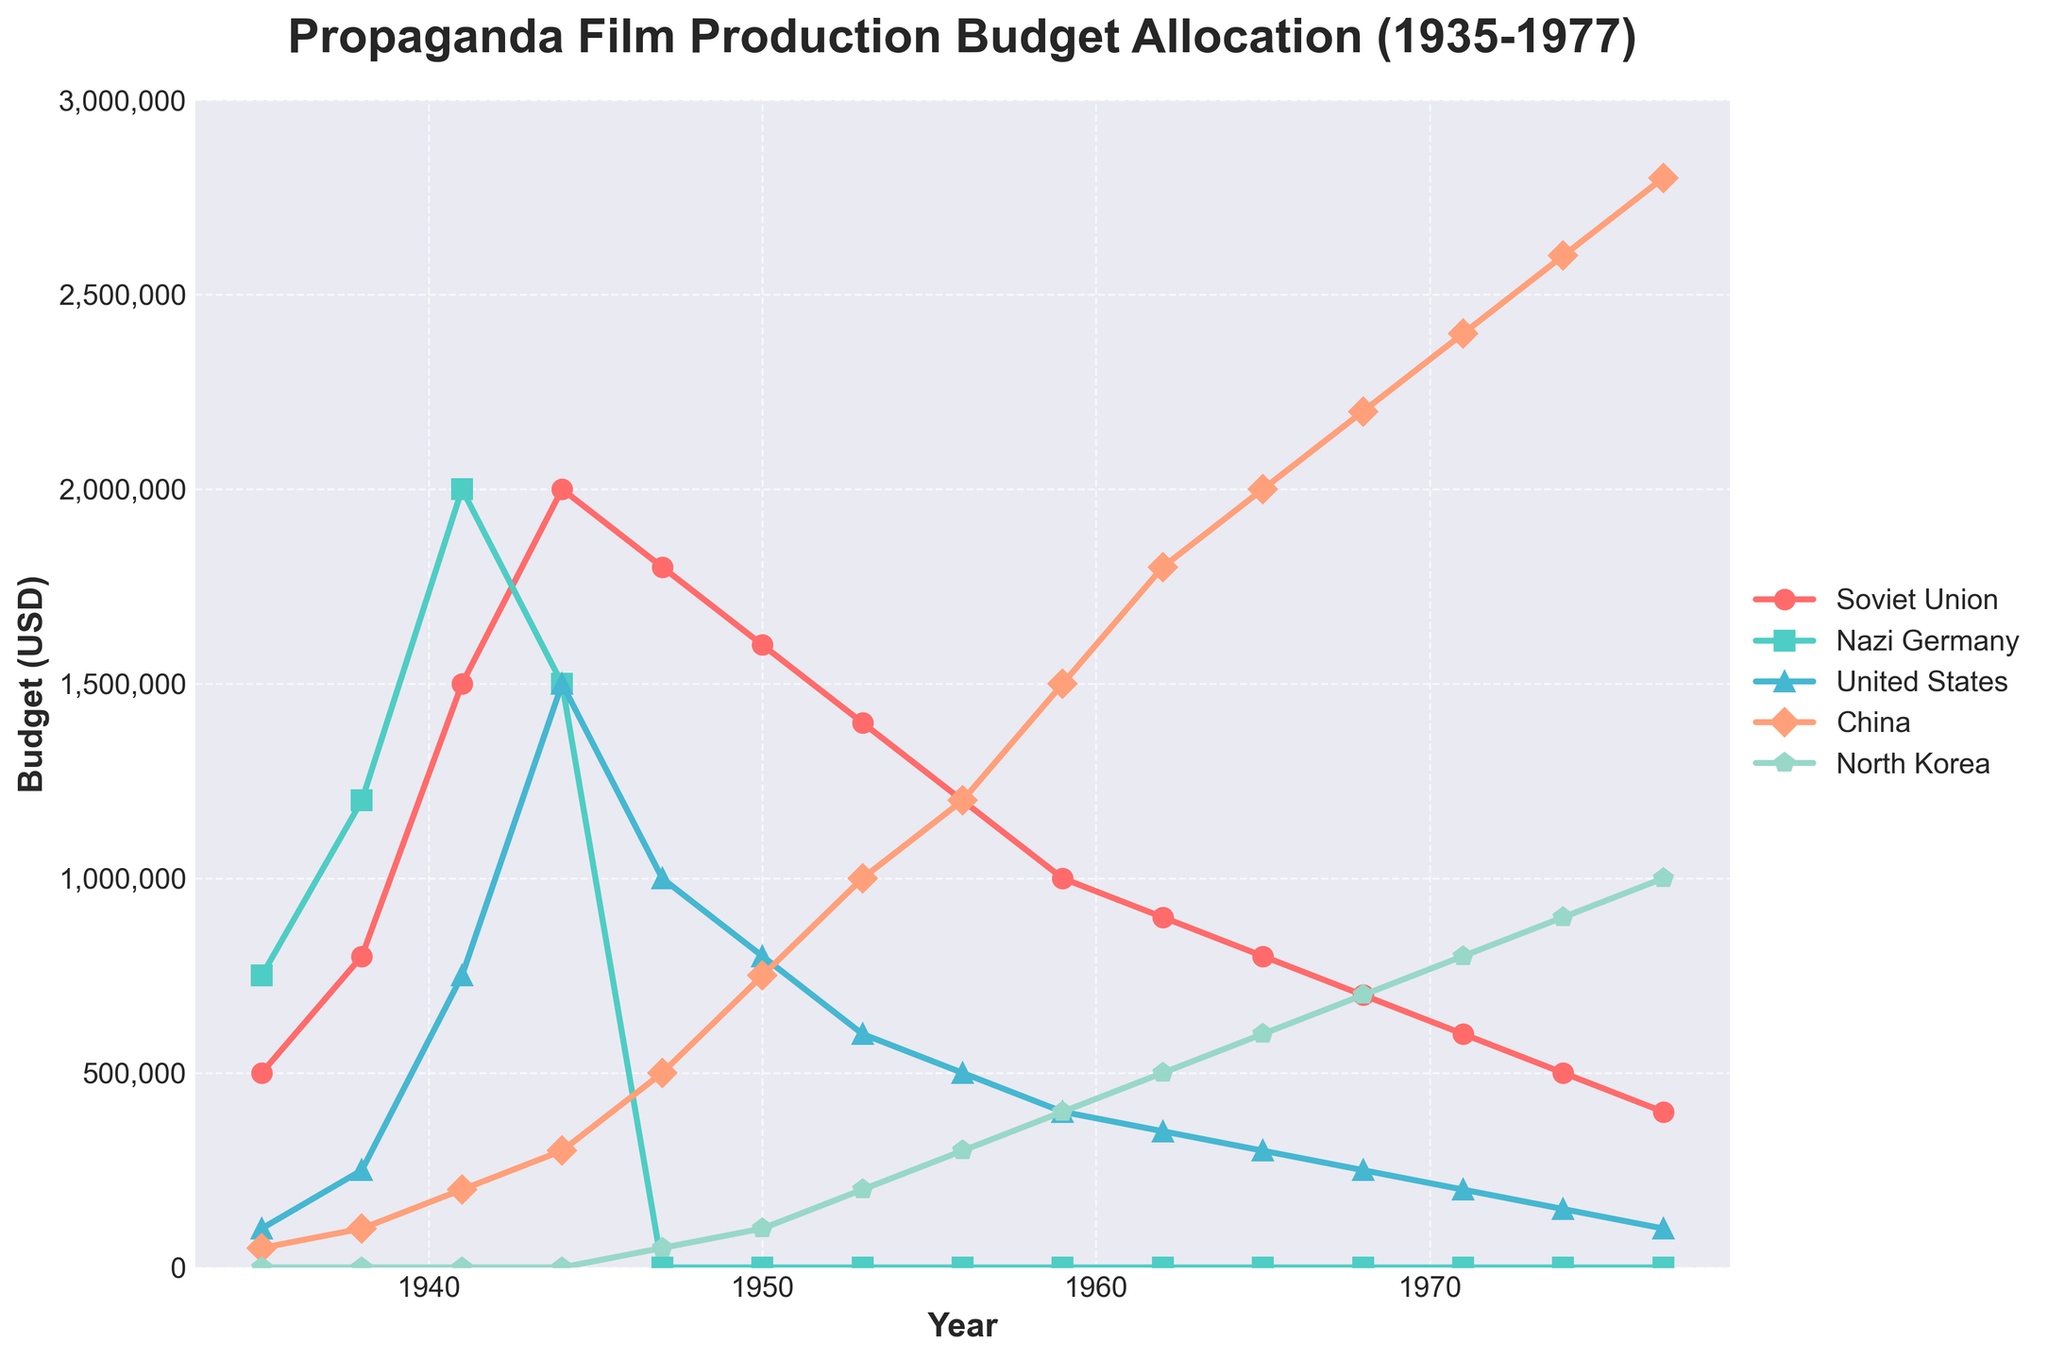What was the budget allocated by China in 1944 and 1977? In 1944, China's budget is marked at 300,000 USD, and in 1977, the budget is marked at 2,800,000 USD.
Answer: 300,000 USD and 2,800,000 USD During which year did the Soviet Union have its highest budget allocation for propaganda film production? The peak for the Soviet Union's budget allocation is marked in the year 1944 with a value of 2,000,000 USD.
Answer: 1944 Between 1935 and 1977, during which period did North Korea's budget increase the most? The most significant increase appears between 1965 (600,000 USD) and 1968 (700,000 USD). The steps show a steady rise, the most marked increment happening between these years.
Answer: 1965-1968 Which country had the highest budget in 1938? In 1938, Nazi Germany had the highest budget allocation, marked at 1,200,000 USD.
Answer: Nazi Germany Calculate the average budget allocation of the United States from 1935 to 1950. The given values: [100,000, 250,000, 750,000, 1,500,000, 1,000,000] sum to 4,600,000. The total data points are 6, thus the average = 4,600,000 / 6 = 766,667 USD.
Answer: 766,667 USD By what year did China's budget allocation exceed that of the Soviet Union? By visually comparing the two lines, China's budget exceeded the Soviet Union's around the year 1956 when China's allocation reached 1,200,000 USD and the Soviet Union's budget was 1,200,000 USD.
Answer: 1956 Was there ever a year when China outspent all other countries? Please specify. In 1965, China’s allocation of 2,000,000 USD outspent all other countries, where the next highest was the Soviet Union at 800,000 USD.
Answer: 1965 Compare the budget allocations between North Korea and the United States in 1974. Which country had a higher budget and by how much? In 1974, the United States had a budget of 150,000 USD, whereas North Korea had 900,000 USD. The difference is 900,000 - 150,000 = 750,000 USD.
Answer: North Korea by 750,000 USD What is the overall trend for the Soviet Union's budget allocation from 1935 to 1977? The Soviet Union's budget shows an increasing trend from 1935 to 1944, peaks in 1944 at 2,000,000 USD, and then steadily declines to as low as 400,000 USD by 1977.
Answer: Increasing until 1944 and then declining How many years did Nazi Germany allocate a budget for propaganda film production? Based on the visual information, Nazi Germany allocated a budget for 3 years: 1935, 1938, and 1941.
Answer: 3 years 